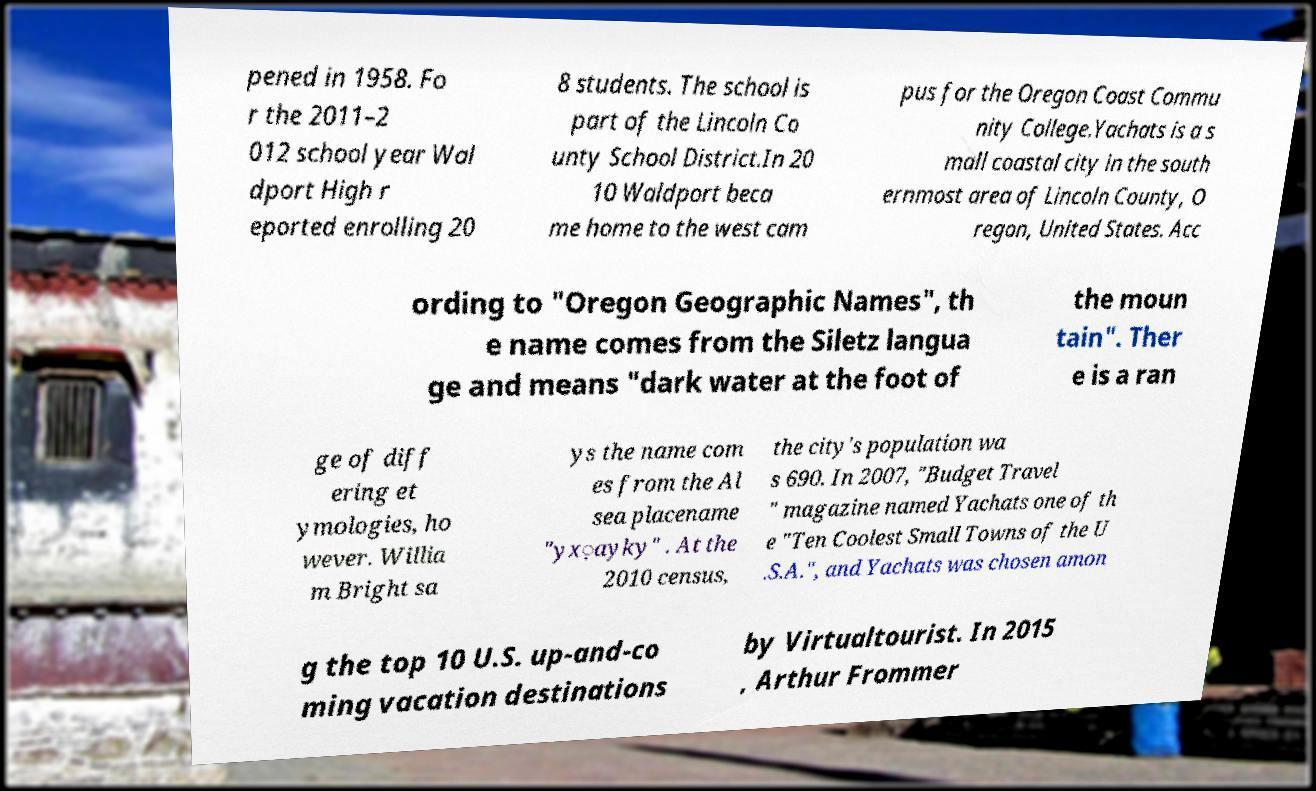Could you assist in decoding the text presented in this image and type it out clearly? pened in 1958. Fo r the 2011–2 012 school year Wal dport High r eported enrolling 20 8 students. The school is part of the Lincoln Co unty School District.In 20 10 Waldport beca me home to the west cam pus for the Oregon Coast Commu nity College.Yachats is a s mall coastal city in the south ernmost area of Lincoln County, O regon, United States. Acc ording to "Oregon Geographic Names", th e name comes from the Siletz langua ge and means "dark water at the foot of the moun tain". Ther e is a ran ge of diff ering et ymologies, ho wever. Willia m Bright sa ys the name com es from the Al sea placename "yx̣ayky" . At the 2010 census, the city's population wa s 690. In 2007, "Budget Travel " magazine named Yachats one of th e "Ten Coolest Small Towns of the U .S.A.", and Yachats was chosen amon g the top 10 U.S. up-and-co ming vacation destinations by Virtualtourist. In 2015 , Arthur Frommer 